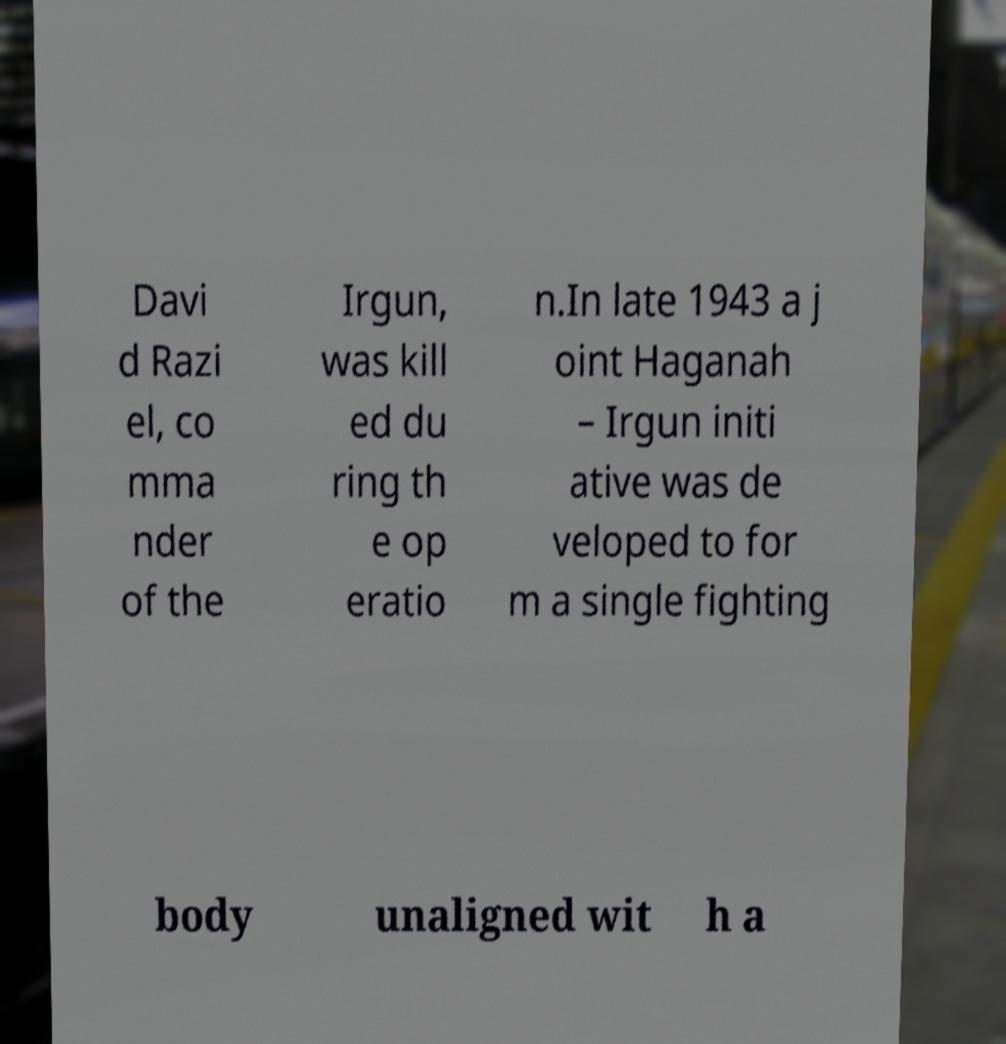What messages or text are displayed in this image? I need them in a readable, typed format. Davi d Razi el, co mma nder of the Irgun, was kill ed du ring th e op eratio n.In late 1943 a j oint Haganah – Irgun initi ative was de veloped to for m a single fighting body unaligned wit h a 